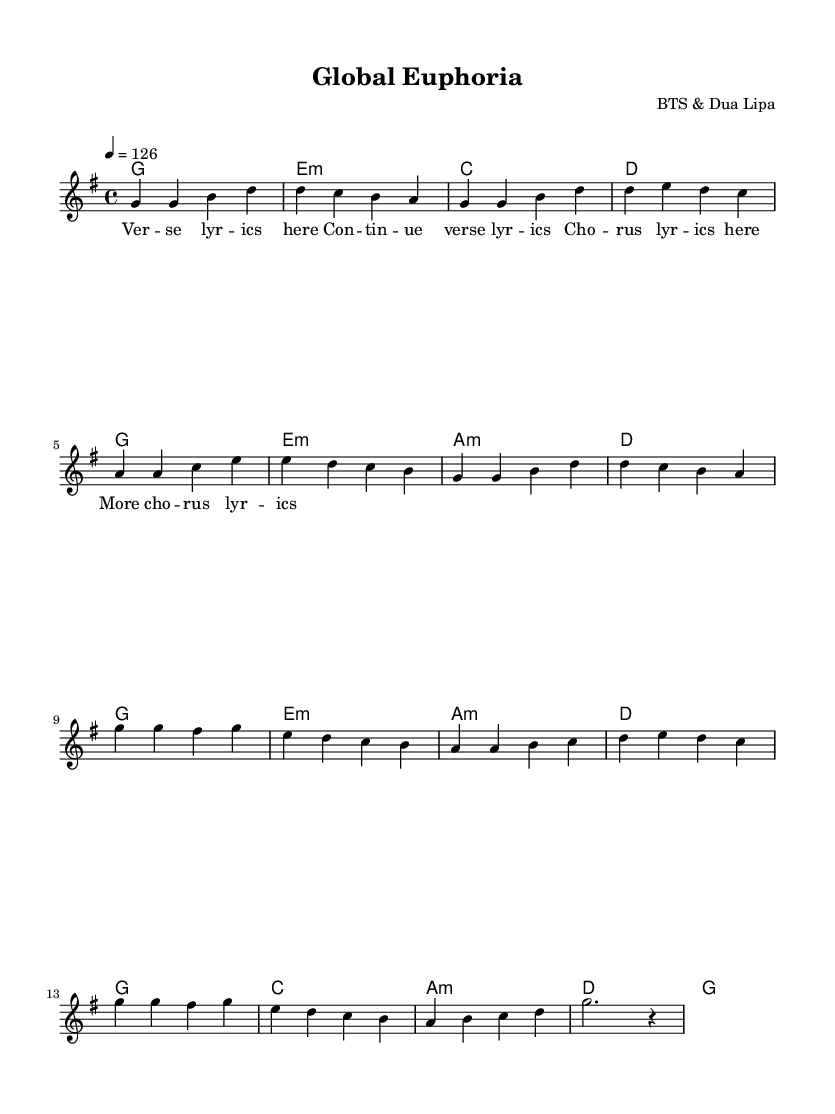What is the key signature of this music? The key signature is G major, which has one sharp (F#). This is determined by looking at the key signature indicated at the beginning of the score.
Answer: G major What is the time signature of this music? The time signature is 4/4, which means there are four beats in each measure and the quarter note gets one beat. This is indicated at the beginning of the score just after the key signature.
Answer: 4/4 What is the tempo marking of this piece? The tempo marking is 126 beats per minute, indicated by the note "4 = 126." This tells the performer how fast the music should be played.
Answer: 126 How many measures are in the verse section? The verse section consists of 8 measures, which can be counted by looking at how many sets of vertical lines (bar lines) separate the notes in the verse.
Answer: 8 What chord follows the first measure of the chorus? The first chord in the chorus following the corresponding measure is G major, as noted in the chord symbols above the measure. It is visually confirmed by the chord indicated above the musical staff.
Answer: G Which artists collaborated on this piece? The collaborators are BTS and Dua Lipa, as indicated in the header section of the score. It clearly states the composer, who is a combination of the two artists.
Answer: BTS & Dua Lipa 